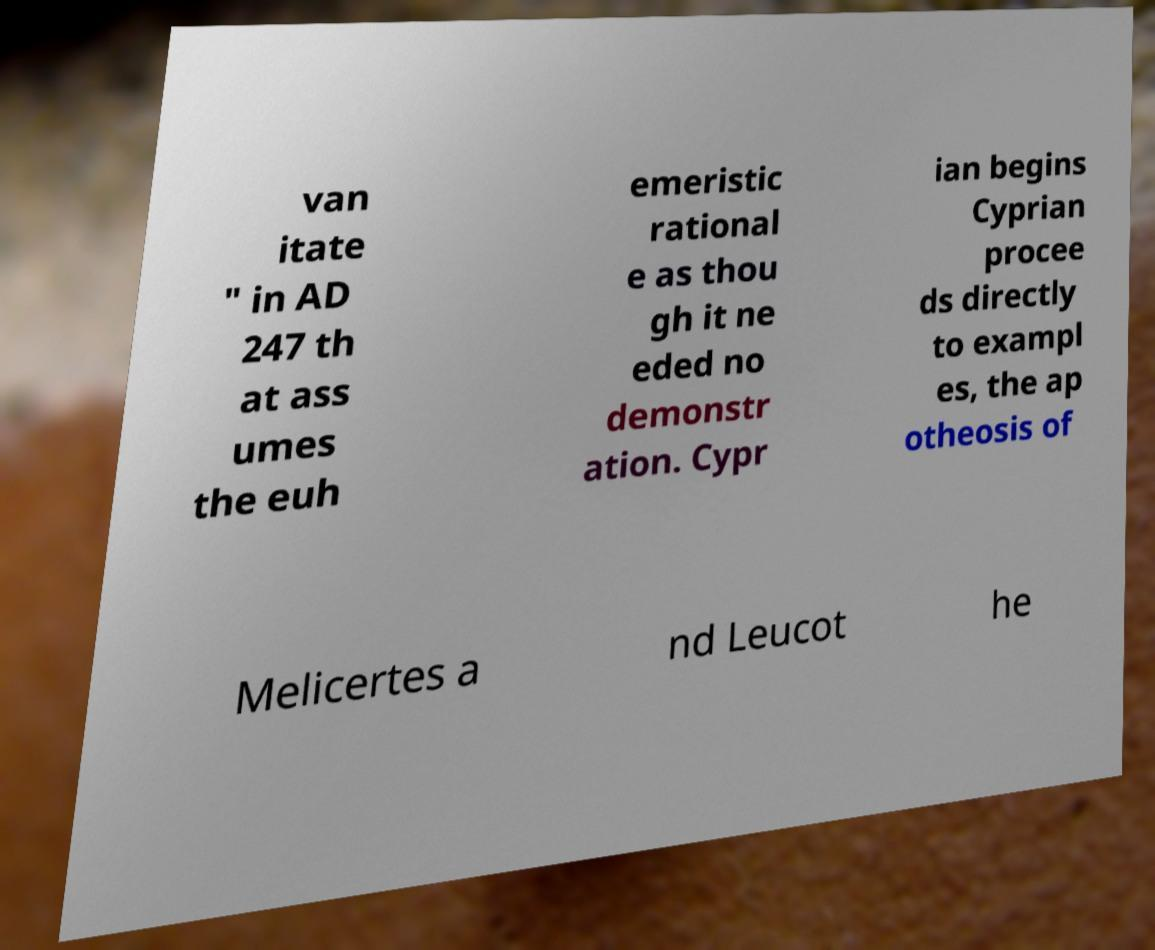Could you extract and type out the text from this image? van itate " in AD 247 th at ass umes the euh emeristic rational e as thou gh it ne eded no demonstr ation. Cypr ian begins Cyprian procee ds directly to exampl es, the ap otheosis of Melicertes a nd Leucot he 